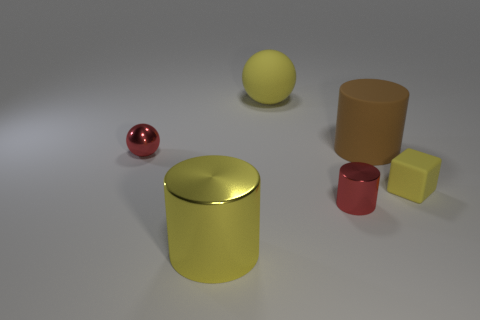Are there the same number of small yellow things that are to the left of the tiny sphere and large objects in front of the red metallic cylinder?
Make the answer very short. No. There is a red metal ball left of the tiny cylinder; how big is it?
Your answer should be compact. Small. The yellow object that is behind the red thing left of the yellow shiny cylinder is made of what material?
Your answer should be compact. Rubber. There is a red thing that is in front of the small object behind the yellow matte cube; how many things are in front of it?
Make the answer very short. 1. Is the thing that is behind the big matte cylinder made of the same material as the big yellow thing in front of the rubber block?
Offer a very short reply. No. There is a big cylinder that is the same color as the large matte sphere; what is its material?
Make the answer very short. Metal. What number of other small yellow rubber things are the same shape as the tiny rubber thing?
Ensure brevity in your answer.  0. Is the number of big yellow metal things on the right side of the red ball greater than the number of big brown matte blocks?
Your answer should be very brief. Yes. There is a tiny red metal thing that is in front of the small object that is to the left of the big yellow object in front of the brown cylinder; what is its shape?
Make the answer very short. Cylinder. There is a yellow rubber object behind the tiny yellow cube; does it have the same shape as the small thing on the left side of the yellow metal thing?
Provide a short and direct response. Yes. 